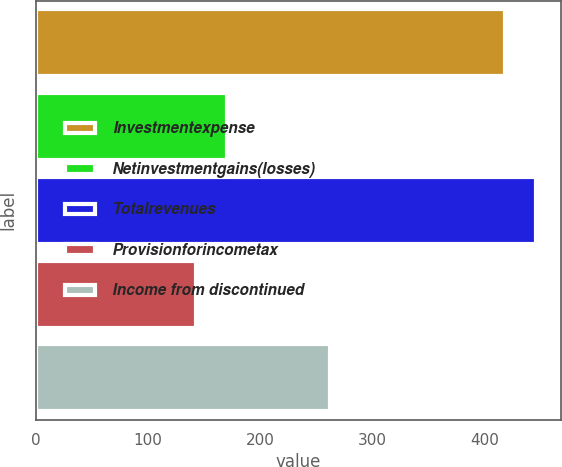Convert chart. <chart><loc_0><loc_0><loc_500><loc_500><bar_chart><fcel>Investmentexpense<fcel>Netinvestmentgains(losses)<fcel>Totalrevenues<fcel>Provisionforincometax<fcel>Income from discontinued<nl><fcel>418<fcel>170.5<fcel>445.5<fcel>143<fcel>262<nl></chart> 